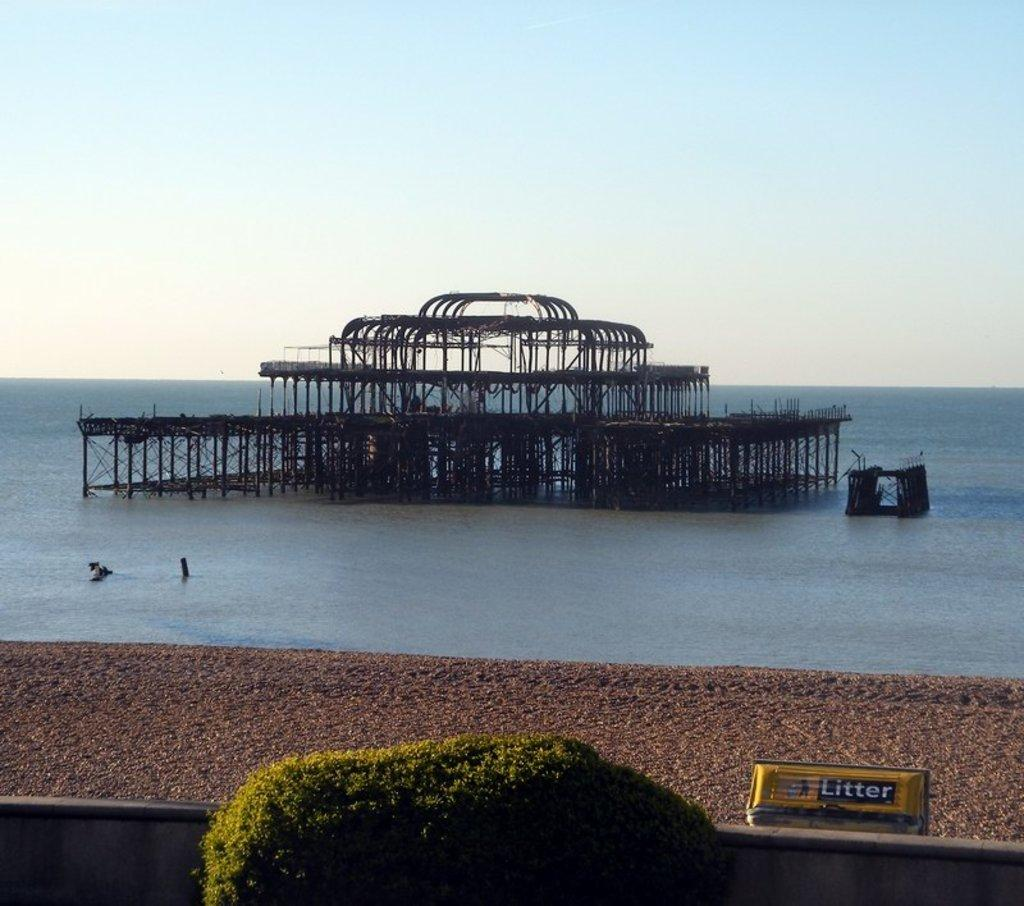What type of natural feature is present in the image? There is a river in the image. What is located in the middle of the river? There is a metal structure in the center of the river. What is in front of the metal structure? There is a fencing wall in front of the metal structure. What is in front of the fencing wall? There is a tree in front of the fencing wall. What is on the surface of the river? There is an object on the surface of the river. What color is the tin umbrella in the image? There is no tin umbrella present in the image. 